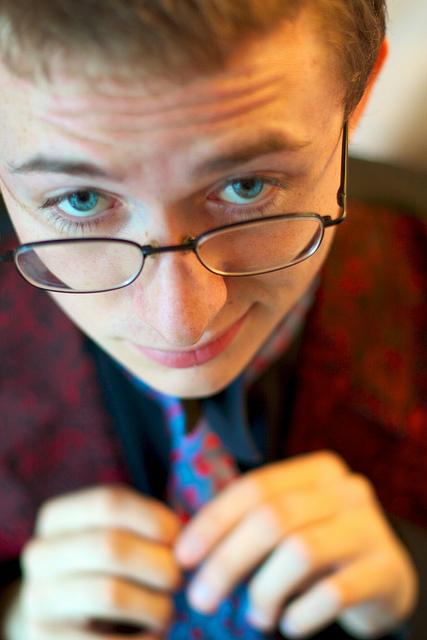Is the man adjusting his tie?
Short answer required. Yes. Is the man wearing glasses?
Be succinct. Yes. What color are the man's eyes?
Keep it brief. Blue. 